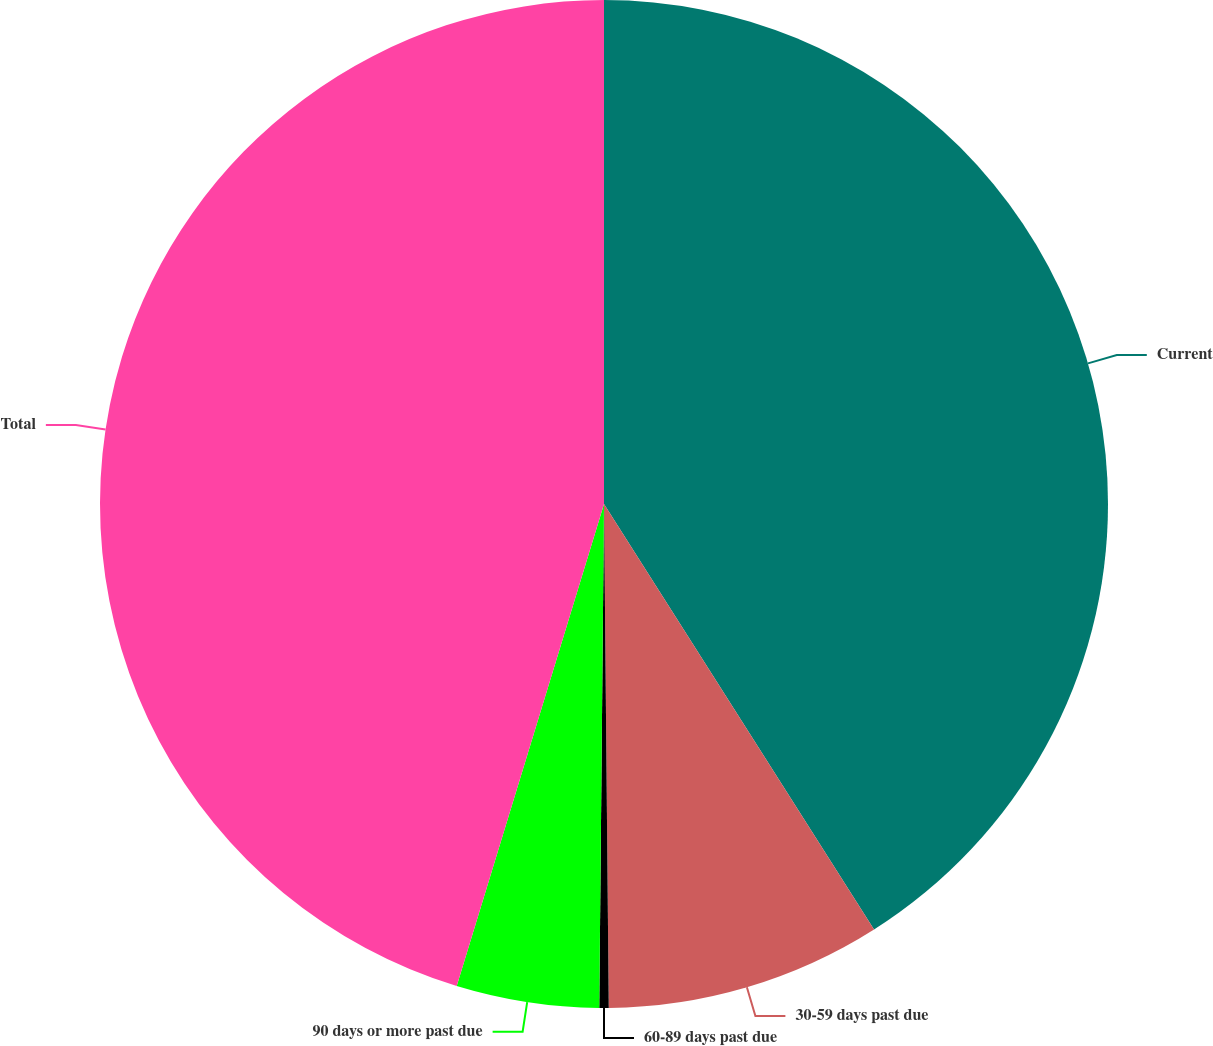<chart> <loc_0><loc_0><loc_500><loc_500><pie_chart><fcel>Current<fcel>30-59 days past due<fcel>60-89 days past due<fcel>90 days or more past due<fcel>Total<nl><fcel>41.0%<fcel>8.85%<fcel>0.3%<fcel>4.57%<fcel>45.28%<nl></chart> 